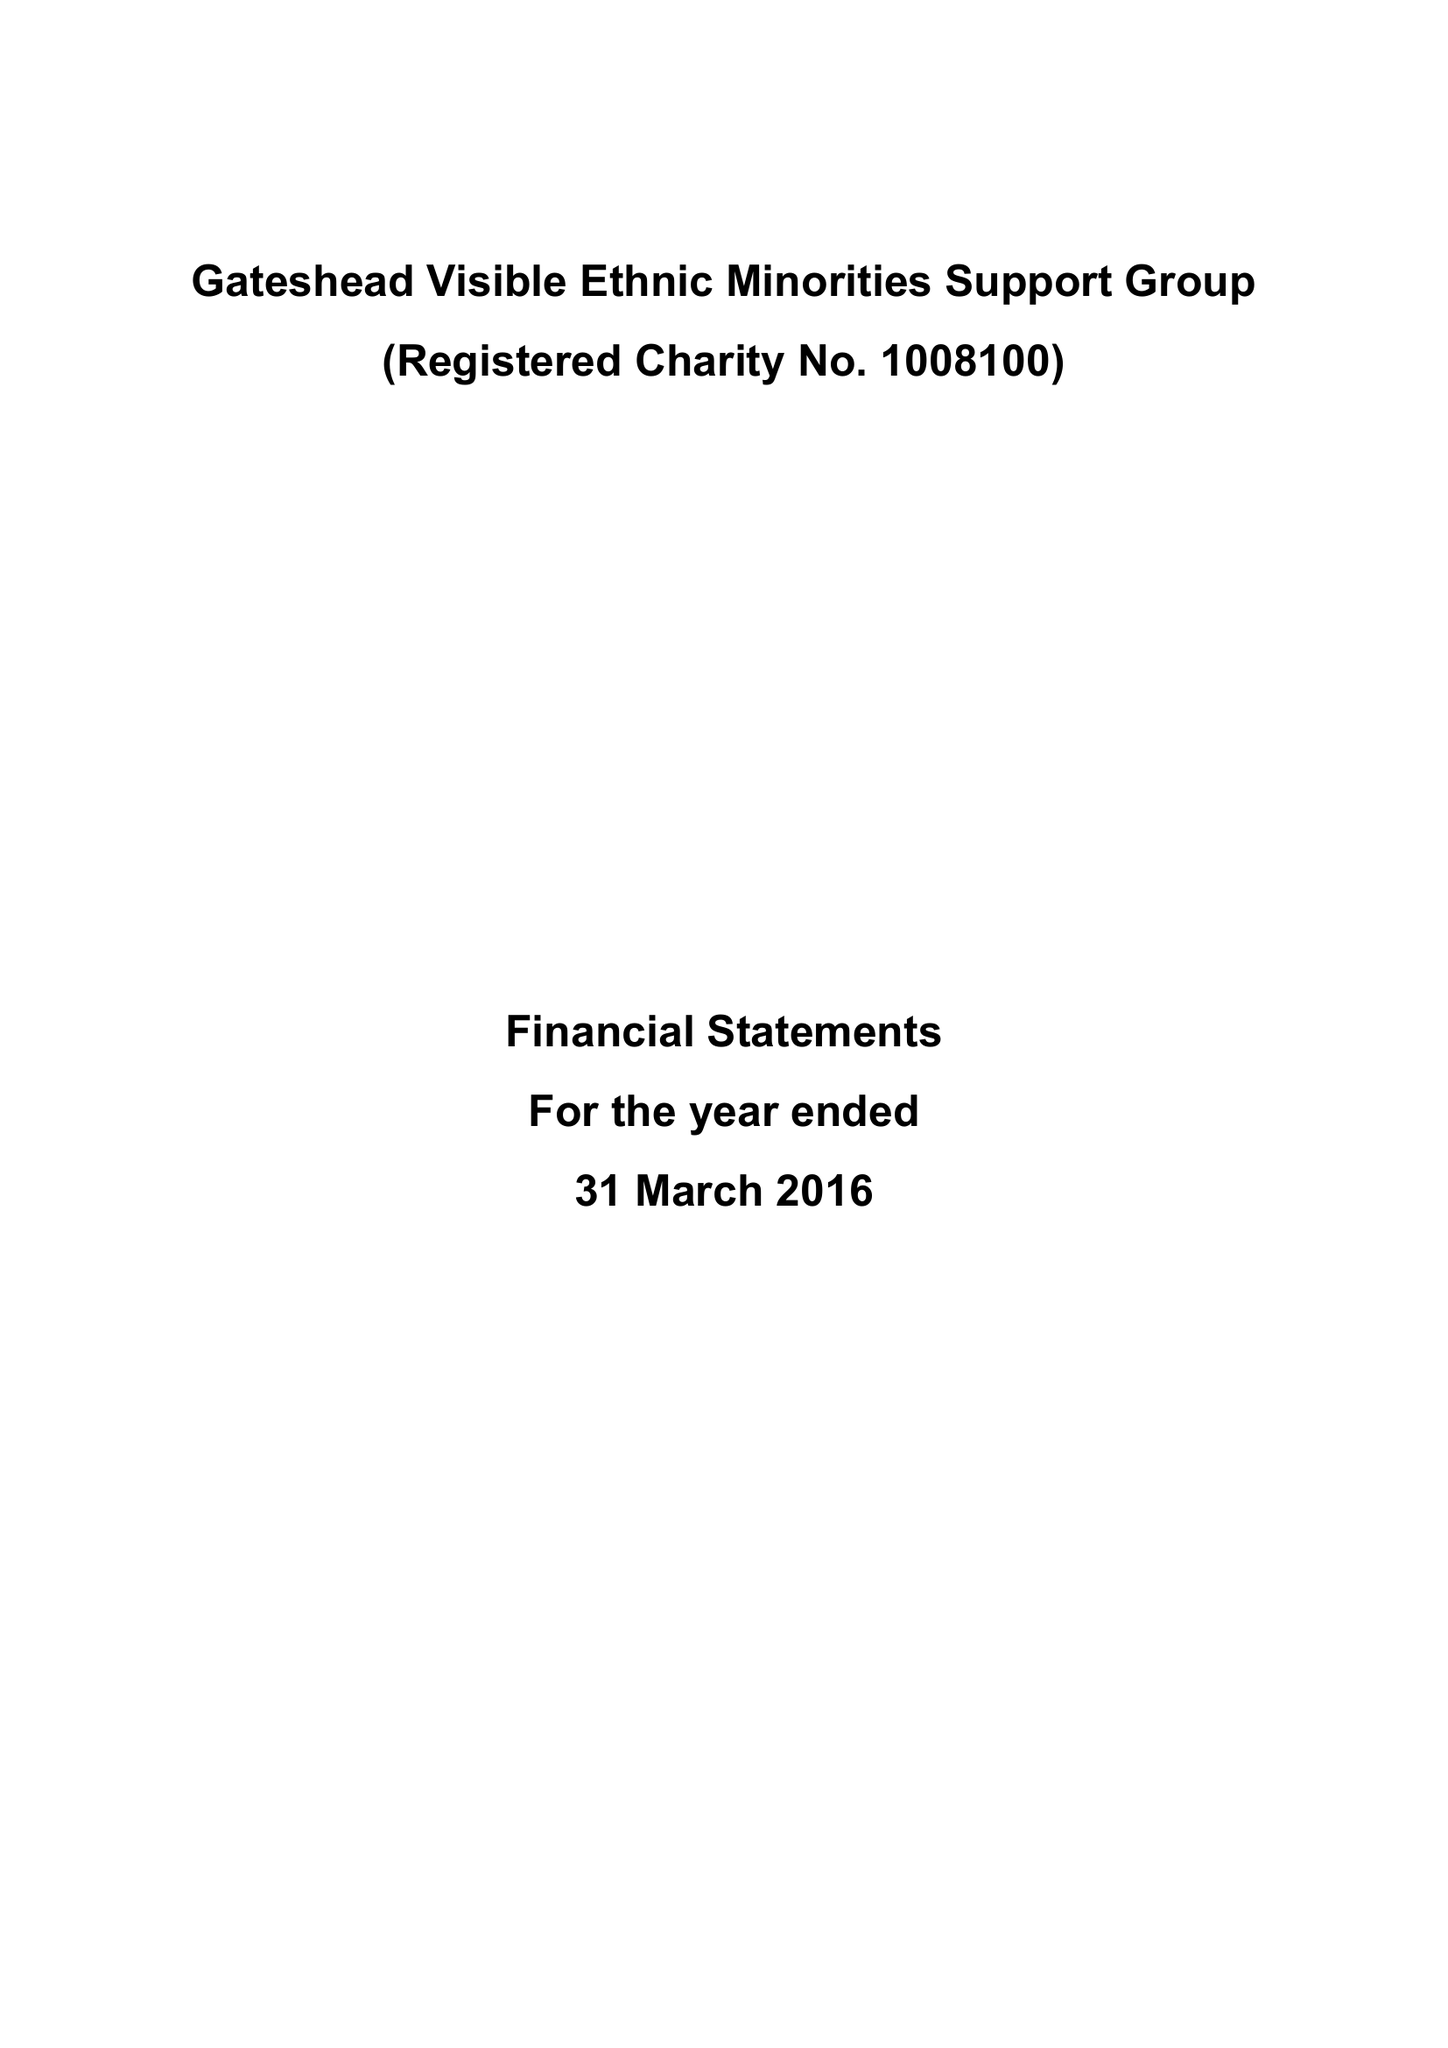What is the value for the spending_annually_in_british_pounds?
Answer the question using a single word or phrase. 211189.00 